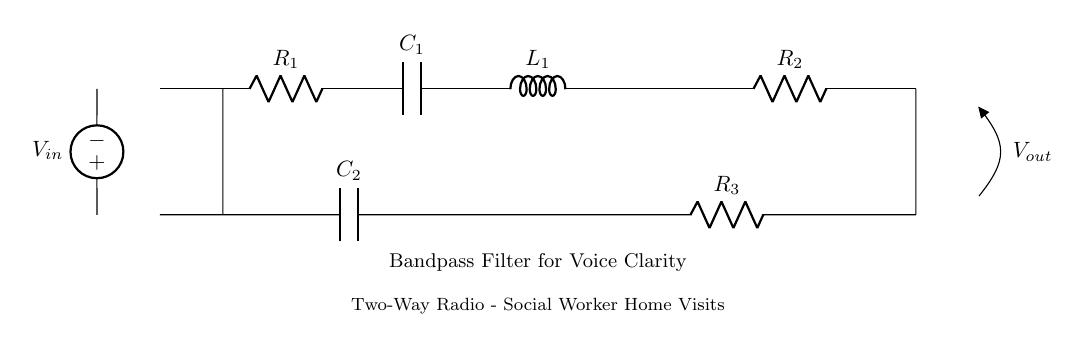What type of filter is represented in this circuit? The circuit is a bandpass filter, designed to allow specific frequencies to pass through while attenuating others. This is indicated by the arrangement of resistors, capacitors, and inductors.
Answer: bandpass filter How many resistors are in the circuit? There are three resistors present in the circuit, as depicted by the labels attached to them.
Answer: three What is the function of capacitor C1 in this circuit? Capacitor C1 works in conjunction with the other components to allow specific frequency ranges to pass, thereby improving voice clarity. The specific function can be deduced from its placement in the filtering arrangement.
Answer: allows specific frequencies Which component is placed at the input of the circuit? The input of the circuit features a voltage source, which provides the signal that will be filtered for clarity.
Answer: voltage source Which components are used to create the bandpass characteristic of the filter? The bandpass characteristic is achieved through the combination of at least one capacitor and one inductor in the circuit. The arrangement enables the desired frequency range to be filtered and passed.
Answer: resistors, capacitors, inductor What is the role of C2 in this bandpass filter circuit? C2 aids in the filtering process by blocking unwanted frequencies while allowing desired frequencies to pass. Its specific role enhances the overall performance of the filter alongside other components.
Answer: blocks unwanted frequencies What is the output voltage connected to in this circuit? The output voltage is connected to an open terminal, designated as Vout, which carries the filtered signal away from the circuit for use. This is indicated by the labeling in the diagram.
Answer: open terminal 